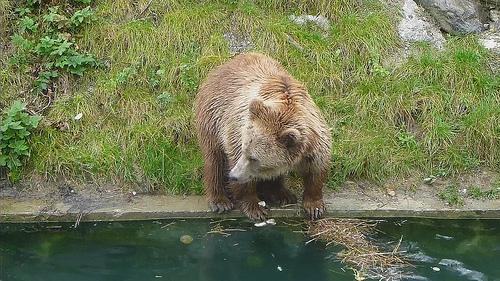How many bears are in this photo?
Give a very brief answer. 1. How many ears are visible on the bear?
Give a very brief answer. 2. 